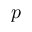Convert formula to latex. <formula><loc_0><loc_0><loc_500><loc_500>p</formula> 